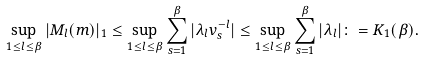Convert formula to latex. <formula><loc_0><loc_0><loc_500><loc_500>\sup _ { 1 \leq l \leq \beta } | { M } _ { l } ( m ) | _ { 1 } & \leq \sup _ { 1 \leq l \leq \beta } \sum _ { s = 1 } ^ { \beta } | \lambda _ { l } v _ { s } ^ { - l } | \leq \sup _ { 1 \leq l \leq \beta } \sum _ { s = 1 } ^ { \beta } | \lambda _ { l } | \colon = K _ { 1 } ( \beta ) .</formula> 